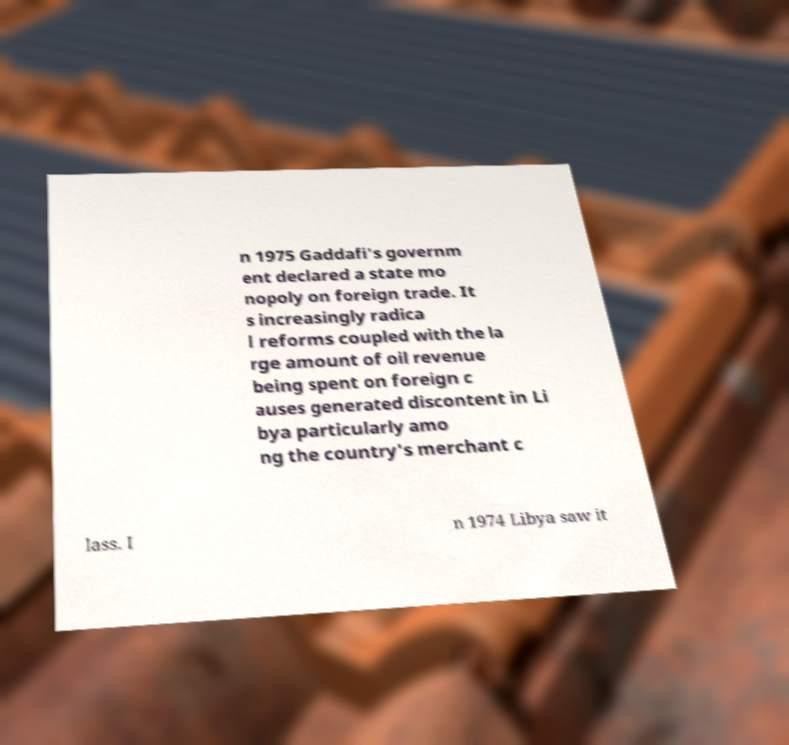Can you accurately transcribe the text from the provided image for me? n 1975 Gaddafi's governm ent declared a state mo nopoly on foreign trade. It s increasingly radica l reforms coupled with the la rge amount of oil revenue being spent on foreign c auses generated discontent in Li bya particularly amo ng the country's merchant c lass. I n 1974 Libya saw it 